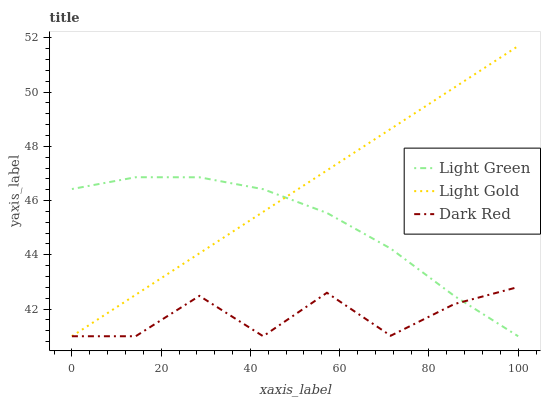Does Dark Red have the minimum area under the curve?
Answer yes or no. Yes. Does Light Gold have the maximum area under the curve?
Answer yes or no. Yes. Does Light Green have the minimum area under the curve?
Answer yes or no. No. Does Light Green have the maximum area under the curve?
Answer yes or no. No. Is Light Gold the smoothest?
Answer yes or no. Yes. Is Dark Red the roughest?
Answer yes or no. Yes. Is Light Green the smoothest?
Answer yes or no. No. Is Light Green the roughest?
Answer yes or no. No. Does Dark Red have the lowest value?
Answer yes or no. Yes. Does Light Gold have the highest value?
Answer yes or no. Yes. Does Light Green have the highest value?
Answer yes or no. No. Does Dark Red intersect Light Green?
Answer yes or no. Yes. Is Dark Red less than Light Green?
Answer yes or no. No. Is Dark Red greater than Light Green?
Answer yes or no. No. 